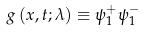Convert formula to latex. <formula><loc_0><loc_0><loc_500><loc_500>g \left ( x , t ; \lambda \right ) \equiv \psi _ { 1 } ^ { + } \psi _ { 1 } ^ { - }</formula> 